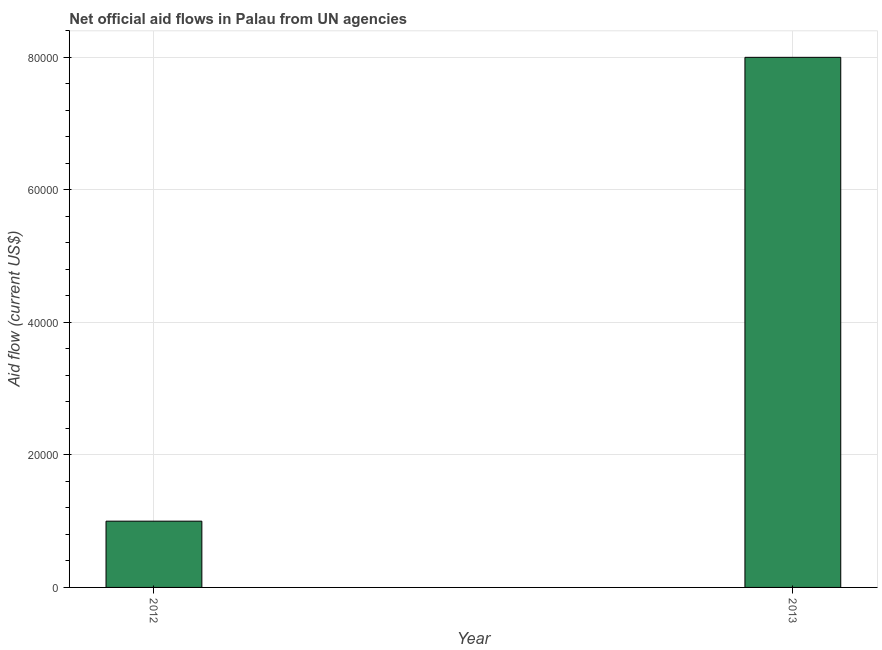What is the title of the graph?
Ensure brevity in your answer.  Net official aid flows in Palau from UN agencies. What is the label or title of the Y-axis?
Your answer should be very brief. Aid flow (current US$). Across all years, what is the minimum net official flows from un agencies?
Ensure brevity in your answer.  10000. What is the sum of the net official flows from un agencies?
Provide a short and direct response. 9.00e+04. What is the average net official flows from un agencies per year?
Provide a short and direct response. 4.50e+04. What is the median net official flows from un agencies?
Your answer should be compact. 4.50e+04. Do a majority of the years between 2013 and 2012 (inclusive) have net official flows from un agencies greater than 72000 US$?
Your answer should be very brief. No. How many bars are there?
Keep it short and to the point. 2. Are all the bars in the graph horizontal?
Keep it short and to the point. No. How many years are there in the graph?
Make the answer very short. 2. Are the values on the major ticks of Y-axis written in scientific E-notation?
Your answer should be compact. No. What is the difference between the Aid flow (current US$) in 2012 and 2013?
Offer a very short reply. -7.00e+04. 